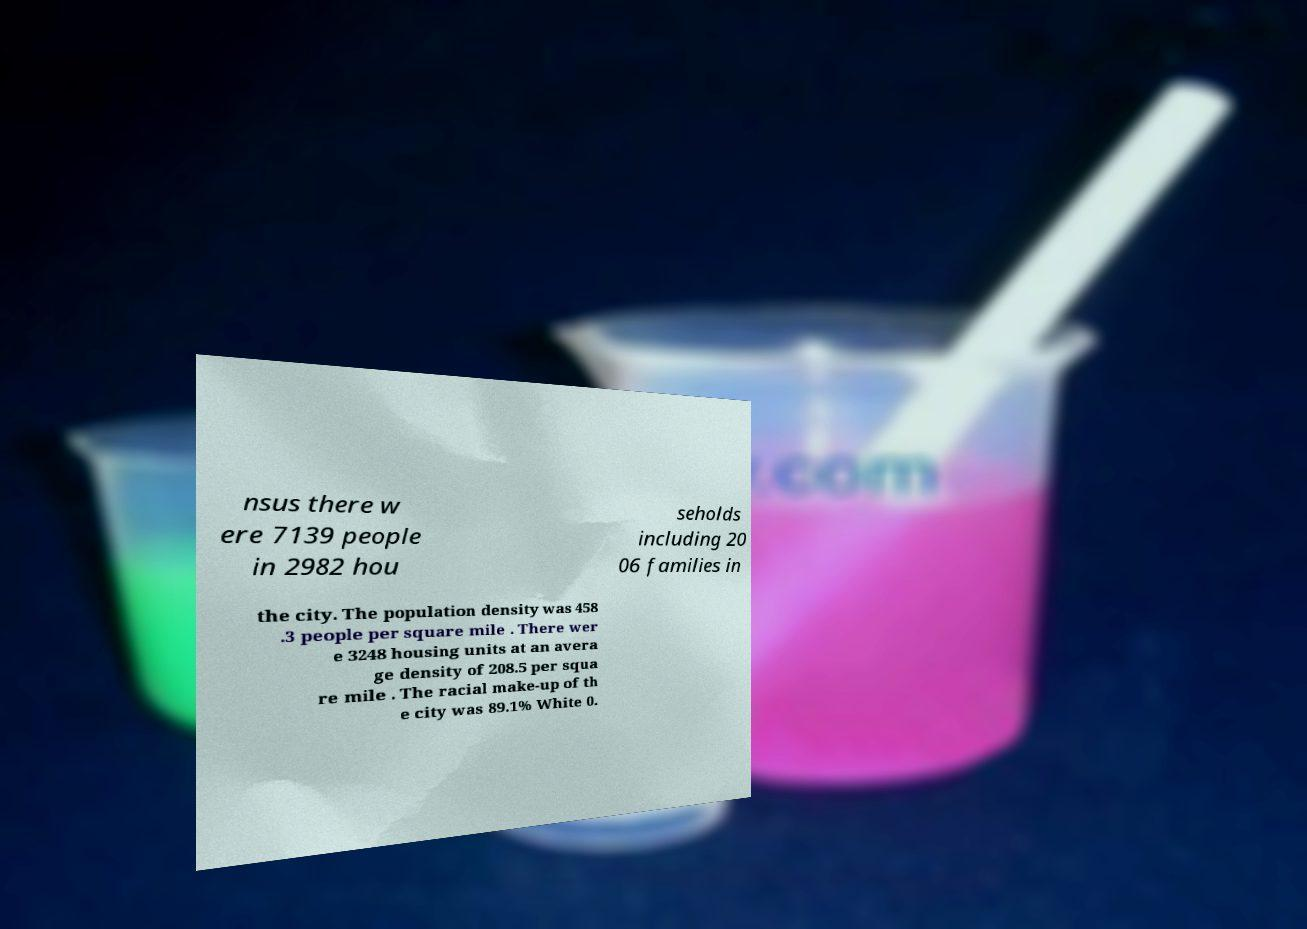Could you assist in decoding the text presented in this image and type it out clearly? nsus there w ere 7139 people in 2982 hou seholds including 20 06 families in the city. The population density was 458 .3 people per square mile . There wer e 3248 housing units at an avera ge density of 208.5 per squa re mile . The racial make-up of th e city was 89.1% White 0. 